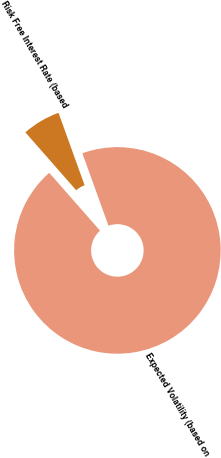Convert chart to OTSL. <chart><loc_0><loc_0><loc_500><loc_500><pie_chart><fcel>Expected Volatility (based on<fcel>Risk Free Interest Rate (based<nl><fcel>94.04%<fcel>5.96%<nl></chart> 